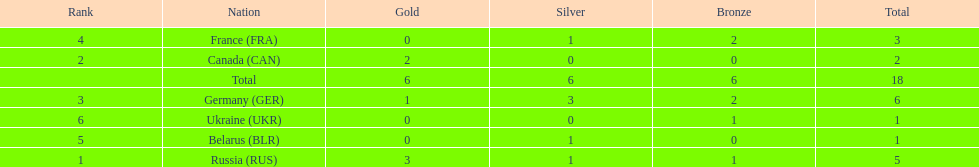Write the full table. {'header': ['Rank', 'Nation', 'Gold', 'Silver', 'Bronze', 'Total'], 'rows': [['4', 'France\xa0(FRA)', '0', '1', '2', '3'], ['2', 'Canada\xa0(CAN)', '2', '0', '0', '2'], ['', 'Total', '6', '6', '6', '18'], ['3', 'Germany\xa0(GER)', '1', '3', '2', '6'], ['6', 'Ukraine\xa0(UKR)', '0', '0', '1', '1'], ['5', 'Belarus\xa0(BLR)', '0', '1', '0', '1'], ['1', 'Russia\xa0(RUS)', '3', '1', '1', '5']]} Name the country that had the same number of bronze medals as russia. Ukraine. 